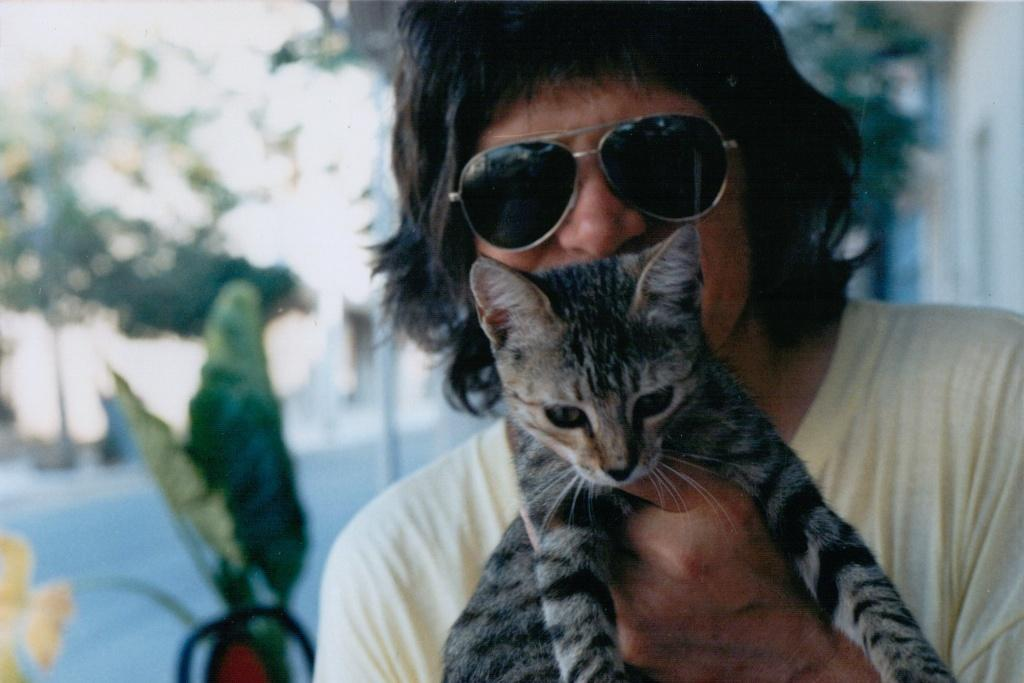Who is present in the image? There is a man in the image. What is the man holding in the image? The man is holding a cat. Can you describe the man's appearance? The man is wearing glasses. What can be seen in the background of the image? There are plants and a road visible in the image. What type of dinosaurs can be seen in the image? There are no dinosaurs present in the image. What does the man wish for in the image? There is no indication of the man making a wish in the image. 